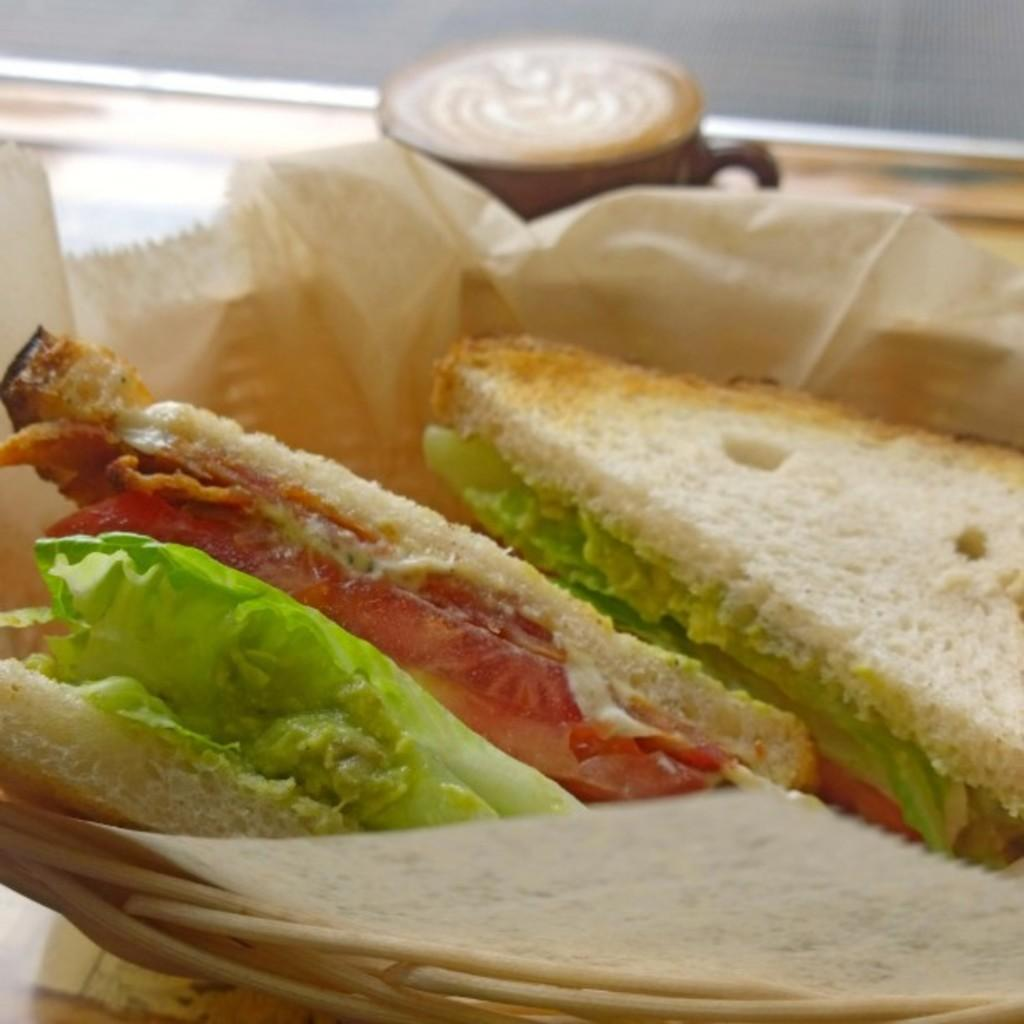What piece of furniture is present in the image? There is a table in the image. What is placed on the table? There is: There is a tray on the table. What is on the tray? The tray contains sandwiches. What else can be seen on the table? There is a cup on the table. What type of drum is being played in the image? There is no drum present in the image. Is there a crown visible on the table in the image? No, there is no crown visible in the image. 